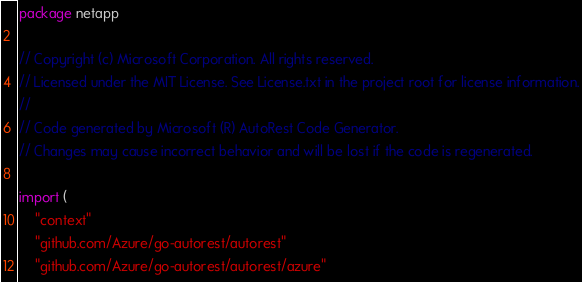<code> <loc_0><loc_0><loc_500><loc_500><_Go_>package netapp

// Copyright (c) Microsoft Corporation. All rights reserved.
// Licensed under the MIT License. See License.txt in the project root for license information.
//
// Code generated by Microsoft (R) AutoRest Code Generator.
// Changes may cause incorrect behavior and will be lost if the code is regenerated.

import (
	"context"
	"github.com/Azure/go-autorest/autorest"
	"github.com/Azure/go-autorest/autorest/azure"</code> 